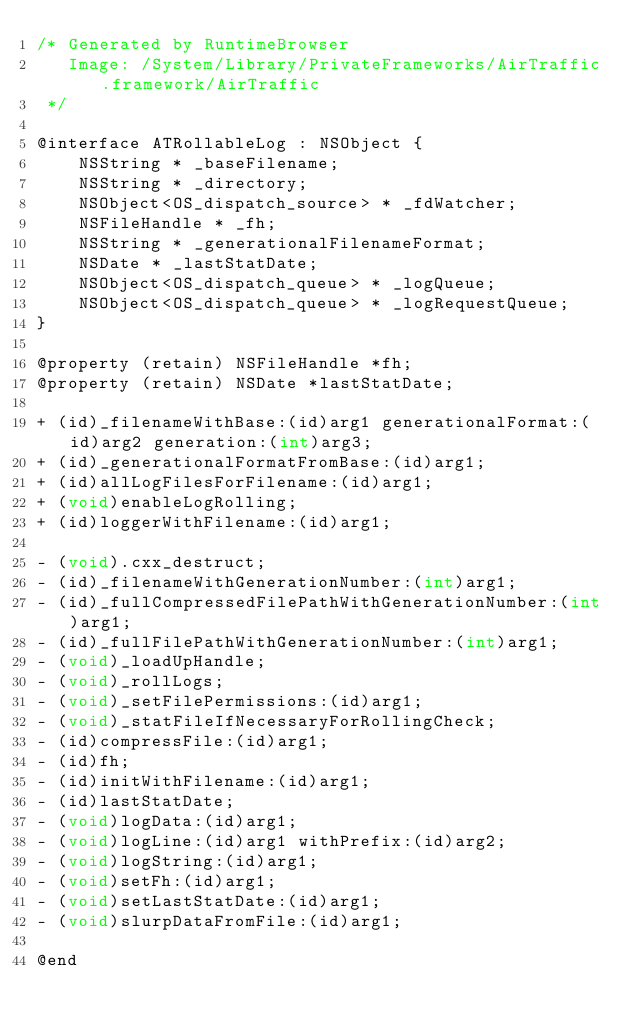Convert code to text. <code><loc_0><loc_0><loc_500><loc_500><_C_>/* Generated by RuntimeBrowser
   Image: /System/Library/PrivateFrameworks/AirTraffic.framework/AirTraffic
 */

@interface ATRollableLog : NSObject {
    NSString * _baseFilename;
    NSString * _directory;
    NSObject<OS_dispatch_source> * _fdWatcher;
    NSFileHandle * _fh;
    NSString * _generationalFilenameFormat;
    NSDate * _lastStatDate;
    NSObject<OS_dispatch_queue> * _logQueue;
    NSObject<OS_dispatch_queue> * _logRequestQueue;
}

@property (retain) NSFileHandle *fh;
@property (retain) NSDate *lastStatDate;

+ (id)_filenameWithBase:(id)arg1 generationalFormat:(id)arg2 generation:(int)arg3;
+ (id)_generationalFormatFromBase:(id)arg1;
+ (id)allLogFilesForFilename:(id)arg1;
+ (void)enableLogRolling;
+ (id)loggerWithFilename:(id)arg1;

- (void).cxx_destruct;
- (id)_filenameWithGenerationNumber:(int)arg1;
- (id)_fullCompressedFilePathWithGenerationNumber:(int)arg1;
- (id)_fullFilePathWithGenerationNumber:(int)arg1;
- (void)_loadUpHandle;
- (void)_rollLogs;
- (void)_setFilePermissions:(id)arg1;
- (void)_statFileIfNecessaryForRollingCheck;
- (id)compressFile:(id)arg1;
- (id)fh;
- (id)initWithFilename:(id)arg1;
- (id)lastStatDate;
- (void)logData:(id)arg1;
- (void)logLine:(id)arg1 withPrefix:(id)arg2;
- (void)logString:(id)arg1;
- (void)setFh:(id)arg1;
- (void)setLastStatDate:(id)arg1;
- (void)slurpDataFromFile:(id)arg1;

@end
</code> 